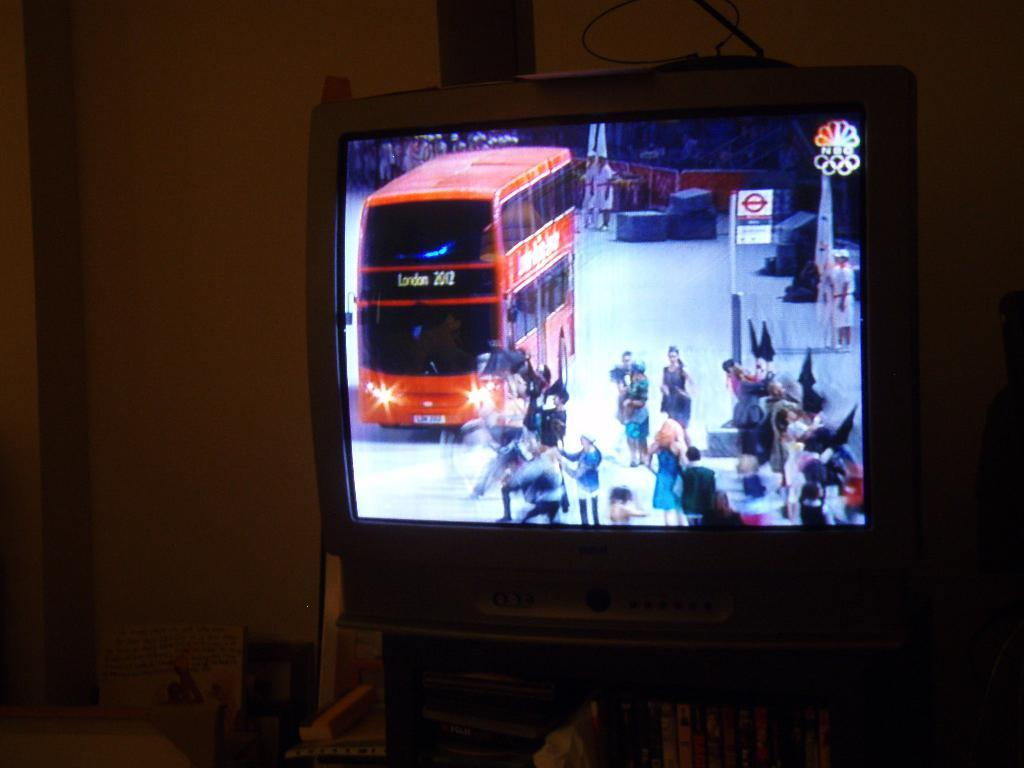<image>
Offer a succinct explanation of the picture presented. The bus numbered 2012 going to London is loading passengers at the bus stop. 